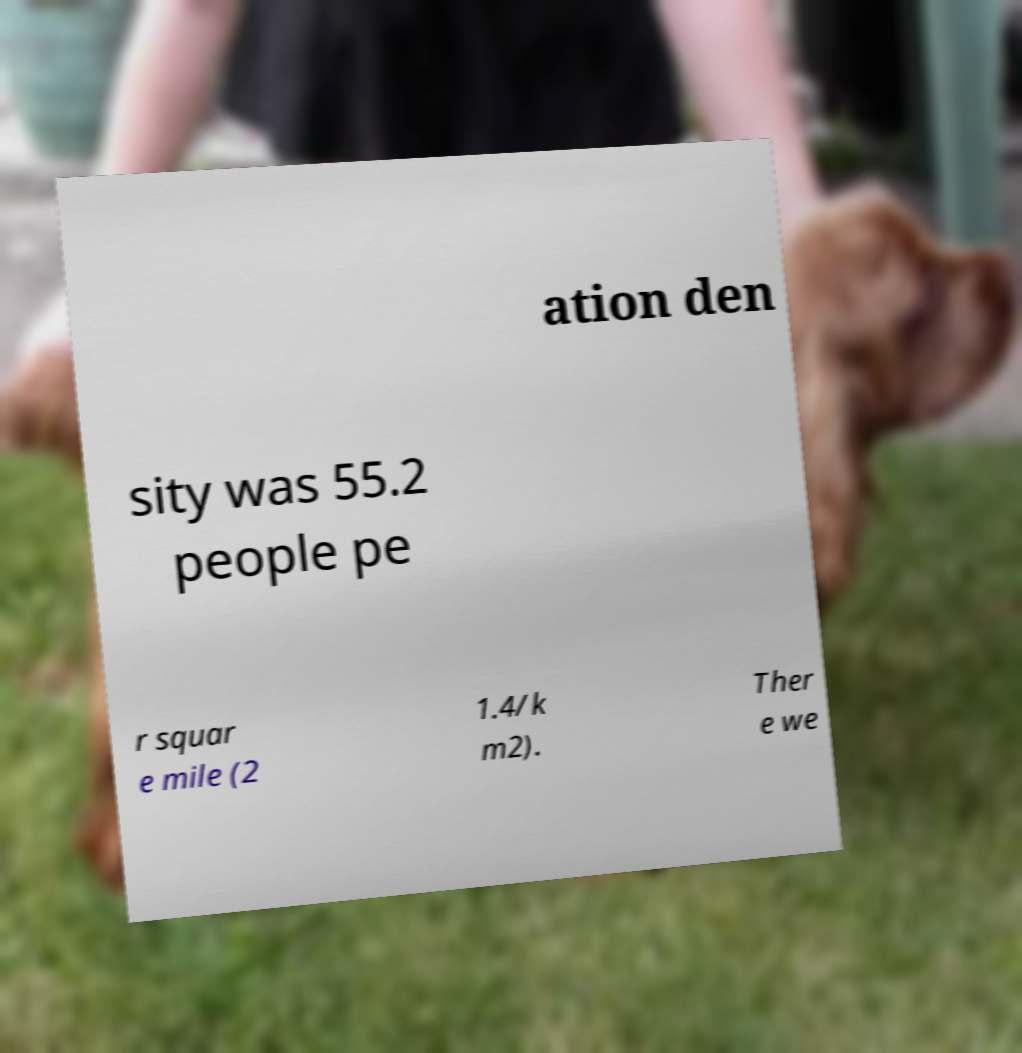Please read and relay the text visible in this image. What does it say? ation den sity was 55.2 people pe r squar e mile (2 1.4/k m2). Ther e we 